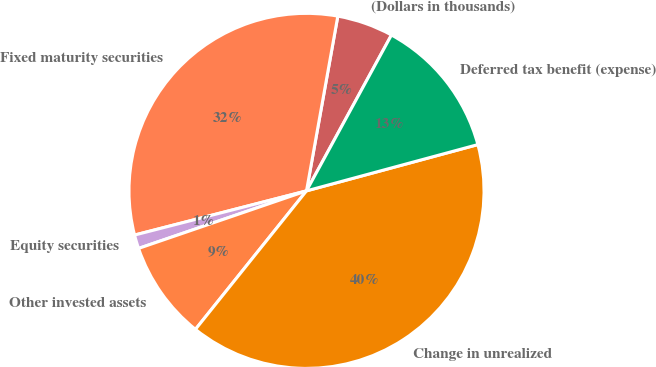Convert chart to OTSL. <chart><loc_0><loc_0><loc_500><loc_500><pie_chart><fcel>(Dollars in thousands)<fcel>Fixed maturity securities<fcel>Equity securities<fcel>Other invested assets<fcel>Change in unrealized<fcel>Deferred tax benefit (expense)<nl><fcel>5.12%<fcel>31.83%<fcel>1.25%<fcel>8.99%<fcel>39.96%<fcel>12.86%<nl></chart> 